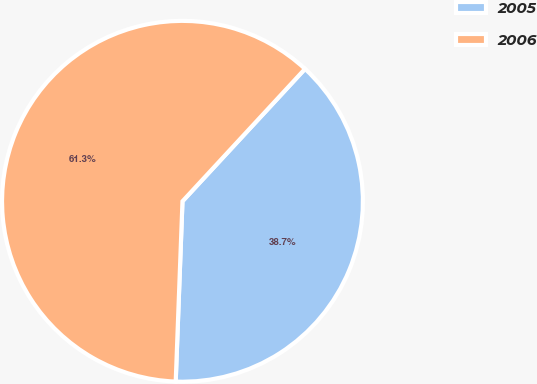Convert chart to OTSL. <chart><loc_0><loc_0><loc_500><loc_500><pie_chart><fcel>2005<fcel>2006<nl><fcel>38.71%<fcel>61.29%<nl></chart> 